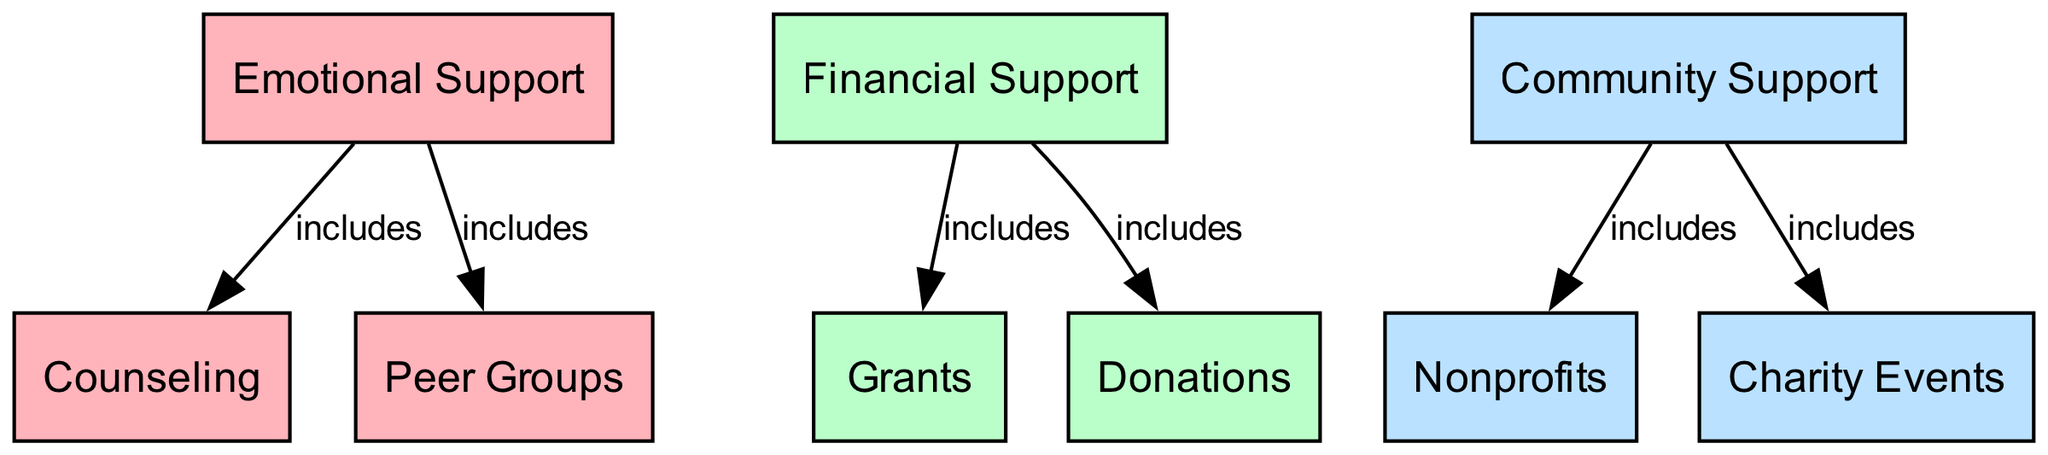What are the three main types of support received by survivors? The diagram displays three main categories of support: Emotional Support, Financial Support, and Community Support. These are the main branches emanating from the center.
Answer: Emotional Support, Financial Support, Community Support How many types of emotional support are included? The emotional support node includes two sub-nodes: Counseling and Peer Groups. By counting these, we find there are two distinct types of emotional support.
Answer: 2 What kind of financial support does the diagram mention? The financial support node includes two sub-nodes: Grants and Donations, each representing a type of financial support provided to survivors.
Answer: Grants, Donations Which type of community support is associated with charity events? The diagram’s community support node links to the Charity Events sub-node, indicating it is a specific type of community support aimed at raising awareness and providing assistance.
Answer: Charity Events What colors are used for the different types of support? The diagram uses three different colors. Emotional Support is represented in pink (#FFB3BA), Financial Support in green (#BAFFC9), and Community Support in blue (#BAE1FF). This visually distinguishes each category of support.
Answer: Pink, Green, Blue Which type of support includes peer groups? Peer Groups is directly linked to the Emotional Support node in the diagram. It is categorized as part of emotional support to signify its role in sharing experiences among survivors.
Answer: Emotional Support Which two sources provide financial support according to the diagram? The financial support node branches to two sources: Grants and Donations. By identifying these, we see that they encompass the ways financial aid is given to survivors.
Answer: Grants, Donations How many edges are connected to emotional support? The emotional support node has two edges stemming from it: one leading to Counseling and another to Peer Groups. This indicates the connections that signify what constitutes emotional support.
Answer: 2 